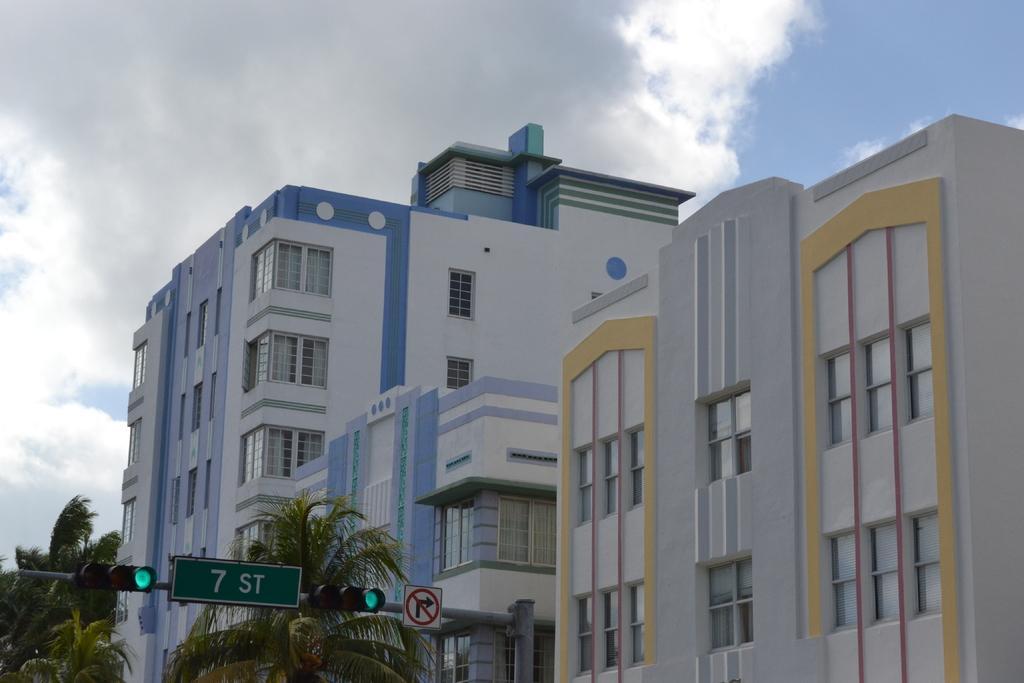How would you summarize this image in a sentence or two? In this image I can see few signal lights, few boards and few poles in the front. On this board I can see something is written and behind it I can see few trees. In the background I can see number of buildings, clouds and the sky. 